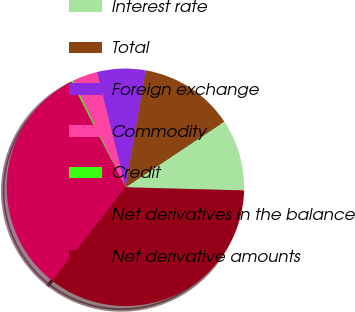<chart> <loc_0><loc_0><loc_500><loc_500><pie_chart><fcel>Interest rate<fcel>Total<fcel>Foreign exchange<fcel>Commodity<fcel>Credit<fcel>Net derivatives in the balance<fcel>Net derivative amounts<nl><fcel>9.76%<fcel>12.93%<fcel>6.59%<fcel>3.42%<fcel>0.25%<fcel>31.94%<fcel>35.11%<nl></chart> 